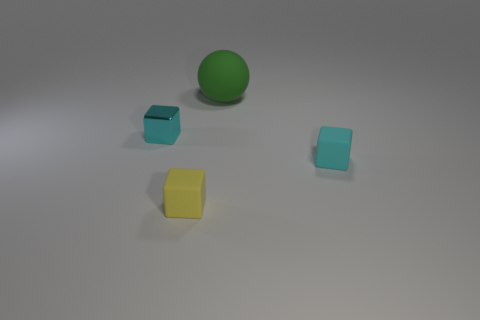There is a tiny cube that is the same color as the metal thing; what material is it?
Ensure brevity in your answer.  Rubber. There is a small object to the right of the yellow object; does it have the same shape as the green thing?
Offer a very short reply. No. Is the number of small yellow blocks to the left of the yellow thing less than the number of large yellow matte spheres?
Your response must be concise. No. Is there a tiny rubber thing of the same color as the small metal thing?
Offer a very short reply. Yes. There is a small metal object; is its shape the same as the cyan object that is to the right of the tiny metallic block?
Offer a terse response. Yes. Are there any cyan cubes made of the same material as the big thing?
Make the answer very short. Yes. Are there any small cyan objects behind the cyan thing that is right of the small cyan block that is left of the yellow rubber thing?
Your answer should be compact. Yes. What number of other objects are there of the same shape as the small yellow matte thing?
Keep it short and to the point. 2. What is the color of the metal cube that is left of the tiny cyan cube to the right of the small cyan block that is left of the big green ball?
Ensure brevity in your answer.  Cyan. What number of green things are there?
Ensure brevity in your answer.  1. 